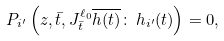<formula> <loc_0><loc_0><loc_500><loc_500>P _ { i ^ { \prime } } \left ( z , \bar { t } , J _ { \bar { t } } ^ { \ell _ { 0 } } \overline { h ( t ) } \colon \, h _ { i ^ { \prime } } ( t ) \right ) = 0 ,</formula> 